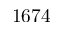<formula> <loc_0><loc_0><loc_500><loc_500>1 6 7 4</formula> 